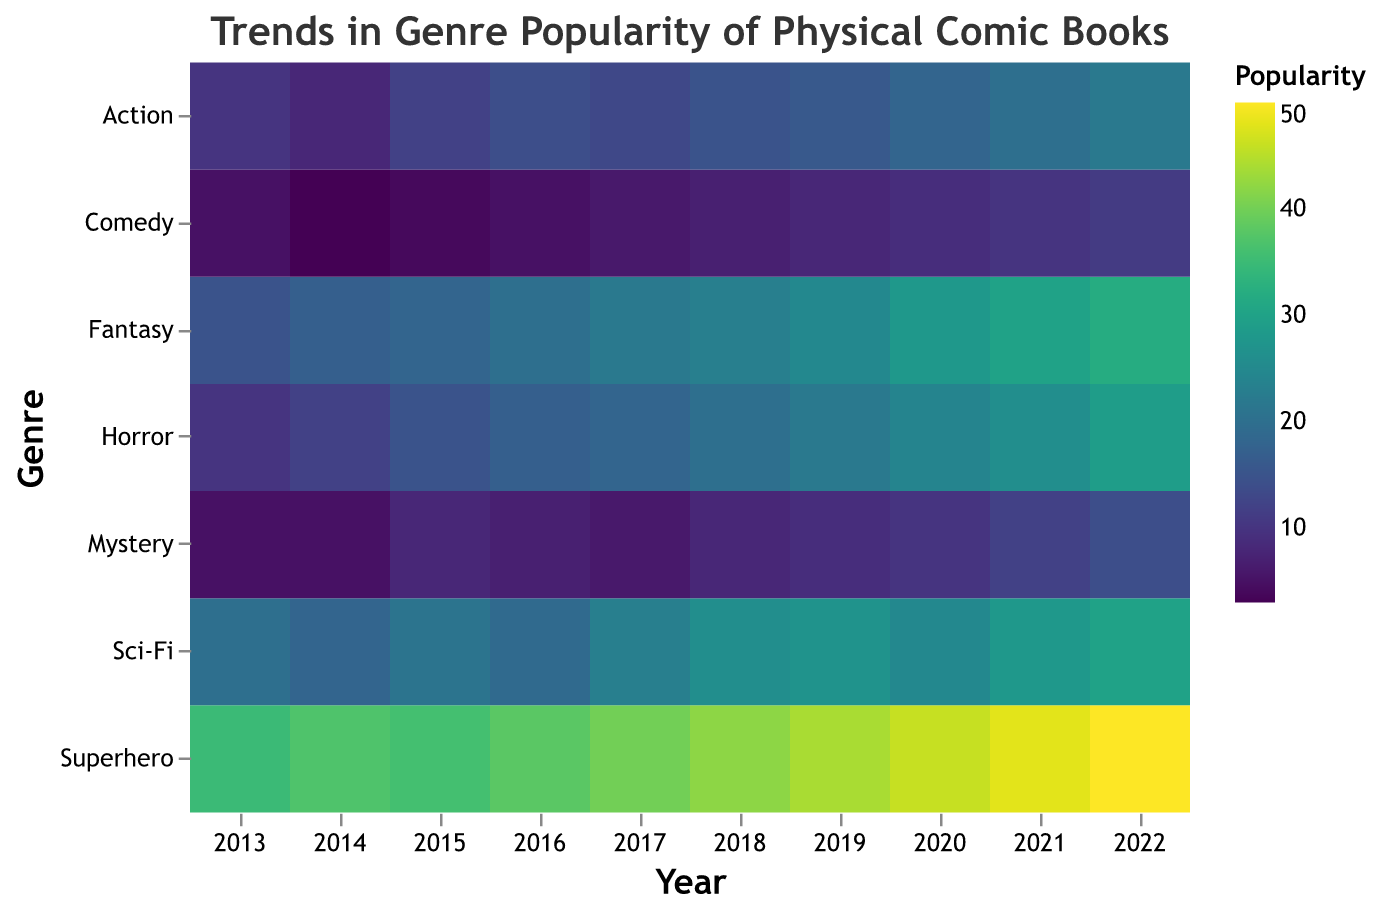How is the popularity of Superhero comics in 2022 compared to 2013? The heatmap shows the popularity of Superhero comics in 2022 is 50, whereas in 2013 it was 35. The difference in popularity is 15.
Answer: 15 Which genre shows the most significant increase in popularity from 2013 to 2022? By comparing the values for each genre in 2013 and 2022, we can see that Superhero increased from 35 to 50, Sci-Fi from 20 to 30, Horror from 10 to 29, Fantasy from 15 to 32, Mystery from 5 to 14, Action from 10 to 22, and Comedy from 5 to 11. Fantasy shows the most significant increase.
Answer: Fantasy What is the trend in the popularity of Horror comics over the decade? Observing the heatmap, we can see the popularity of Horror comics increased consistently from 10 in 2013 to 29 in 2022.
Answer: Increasing Which genres showed a decrease in popularity in any given year within the decade? Observing the heatmap year-by-year, Sci-Fi decreased from 2013 to 2014 and then from 2015 to 2016, and Mystery decreased from 2013 to 2014, 2016 to 2017, 2018 to 2019.
Answer: Sci-Fi and Mystery In which year did Action comics have equal popularity to Comedy comics, and what was their popularity? Looking at the heatmap, we find that in the year 2013, both Action and Comedy comics had a popularity of 10 and in 2018, both Action and Comedy comics had a popularity of 15.
Answer: 2013 and 2018, popularity 10 and 15 respectively Which genre maintained a consistently increasing trend from 2013 to 2022? By analyzing each column for increasing values from 2013 to 2022, Superhero, Horror, Fantasy, and Comedy maintained a consistent increase.
Answer: Superhero, Horror, Fantasy, and Comedy What is the average popularity of Sci-Fi comics over the decade? To find the average, sum the popularity values for Sci-Fi from 2013 to 2022 (20+18+21+19+23+26+27+25+28+30) and divide by 10. The sum is 237, so the average is 237/10.
Answer: 23.7 Which genre experienced the highest growth in popularity between consecutive years? Checking year-to-year differences, Fantasy's popularity jumped from 28 in 2020 to 30 in 2021 and then to 32 in 2022. Therefore, the highest growth was from 2020 to 2021, i.e., 2 units each.
Answer: Fantasy 2020-2021 and 2021-2022 Does any genre show periods of stagnation in its popularity? By examining each genre's year-by-year changes, Mystery shows no change from 2013 to 2014 and from 2016 to 2017, while Comedy shows no change from 2013 to 2014.
Answer: Mystery and Comedy 